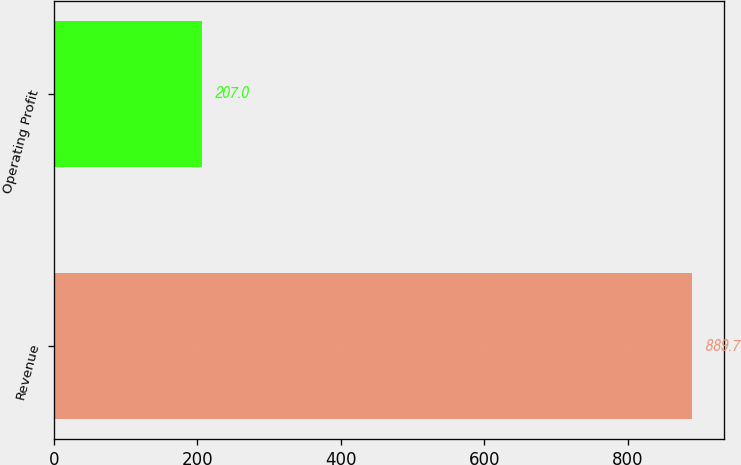Convert chart. <chart><loc_0><loc_0><loc_500><loc_500><bar_chart><fcel>Revenue<fcel>Operating Profit<nl><fcel>889.7<fcel>207<nl></chart> 